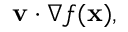Convert formula to latex. <formula><loc_0><loc_0><loc_500><loc_500>v \cdot { \nabla f ( x ) } ,</formula> 